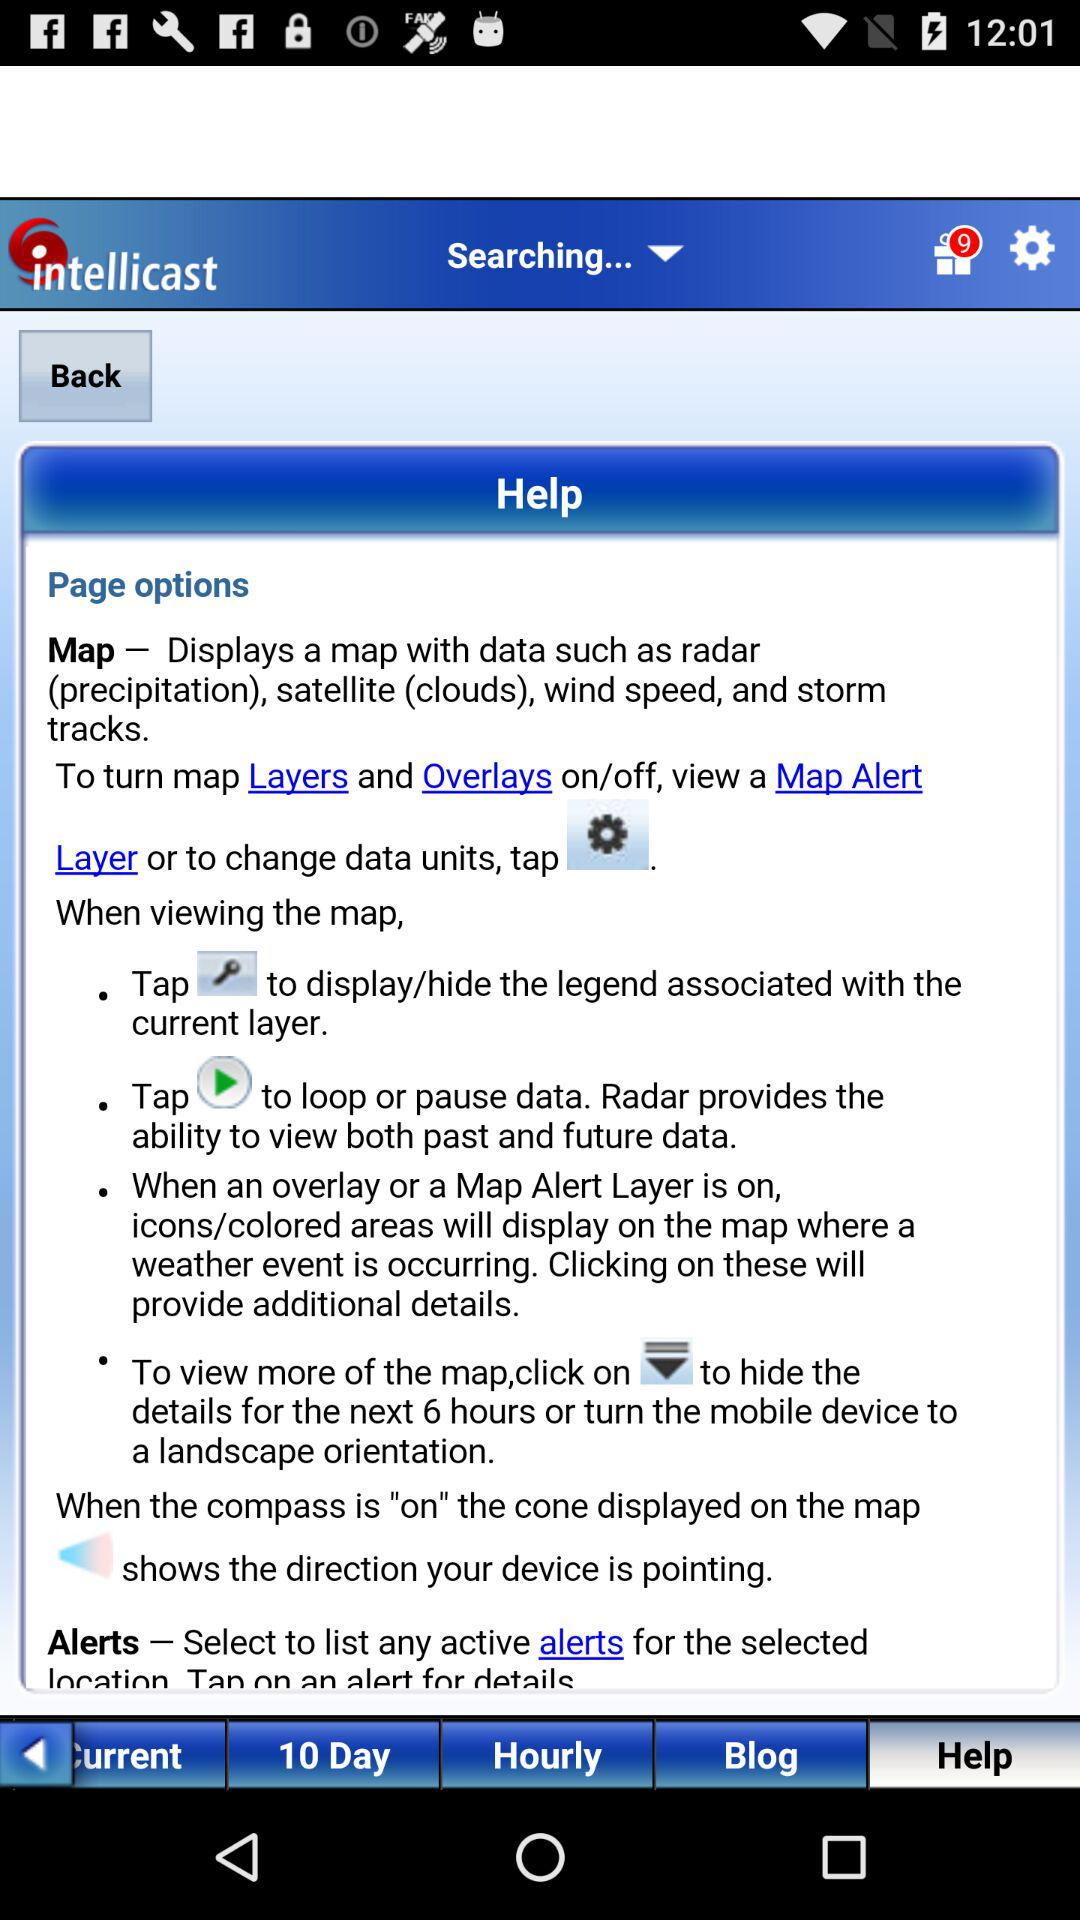What is the application name? The application name is "intellicast". 